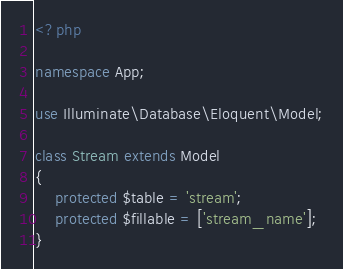<code> <loc_0><loc_0><loc_500><loc_500><_PHP_><?php

namespace App;

use Illuminate\Database\Eloquent\Model;

class Stream extends Model
{
    protected $table = 'stream';
    protected $fillable = ['stream_name'];
}
</code> 